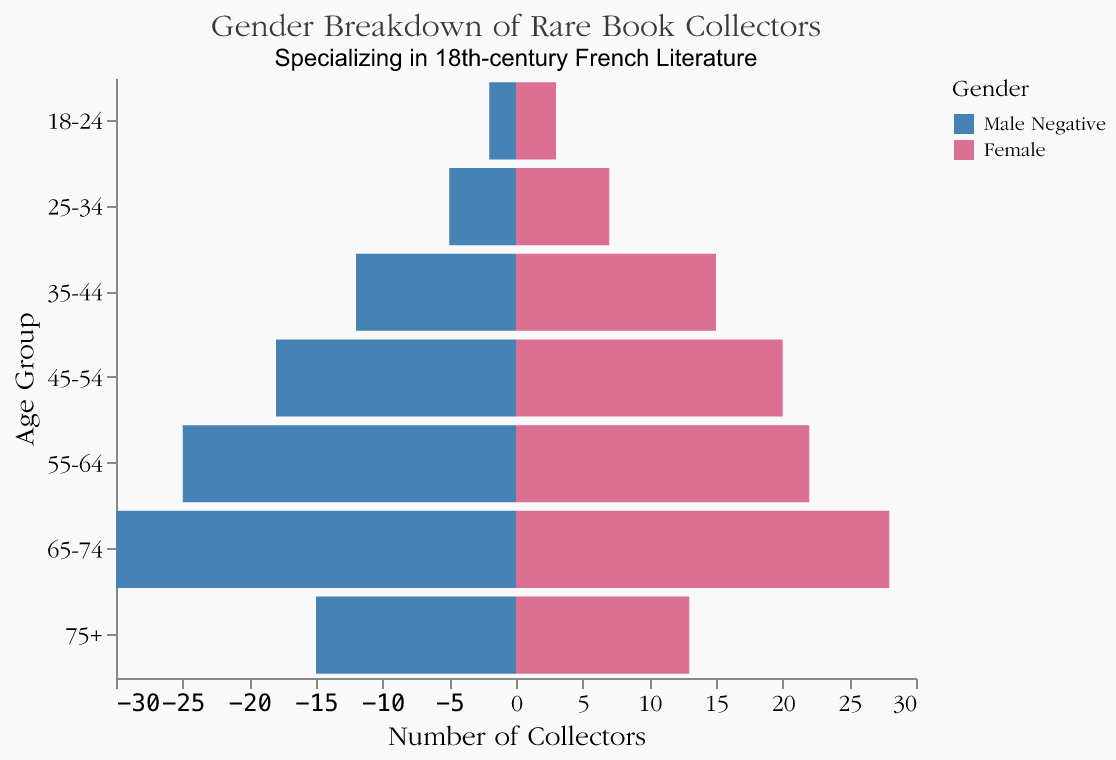What's the title of the figure? The title is positioned at the top of the figure, showing the main subject, which in this case is the gender breakdown of rare book collectors specializing in 18th-century French literature.
Answer: Gender Breakdown of Rare Book Collectors Which gender has more collectors in the 45-54 age group? In the 45-54 age group, the values for males and females can be seen by comparing their bar lengths. The bar for females is slightly longer.
Answer: Female How many total collectors are there in the 65-74 age group? To find this, add the number of male collectors (30) and female collectors (28) in the 65-74 age group. 30 + 28 = 58.
Answer: 58 How many more male collectors are there than female collectors in the 18-24 age group? Subtract the number of female collectors from the number of male collectors in the 18-24 age group: 2 - 3 = -1. This indicates there are more female collectors than male in this age group.
Answer: -1 What's the average number of male collectors across all age groups? Sum the number of male collectors in all age groups and divide by the total number of age groups: (2 + 5 + 12 + 18 + 25 + 30 + 15) / 7 = 107 / 7 ≈ 15.3.
Answer: 15.3 Which age group has the highest number of female collectors? Compare the bar lengths for female collectors across all age groups. The 45-54 age group has the longest bar for females, indicating the highest number.
Answer: 45-54 Which age group has the largest gender disparity in favor of male collectors? Compare the differences between male and female collectors in each age group. The 65-74 age group shows the largest disparity with 30 males versus 28 females.
Answer: 65-74 Is there an age group where the number of male and female collectors is equal? Check each age group for equal bar lengths for both genders. No age group has an equal number of male and female collectors.
Answer: No How does the 55-64 age group's number of female collectors compare to the 75+ age group? Compare the bar lengths of female collectors between these two age groups. The 55-64 age group has 22 female collectors, while the 75+ age group has 13.
Answer: The 55-64 age group has more female collectors By how many does the number of male collectors increase from the 35-44 to the 55-64 age group? Subtract the number of male collectors in the 35-44 age group from those in the 55-64 age group: 25 - 12 = 13.
Answer: 13 